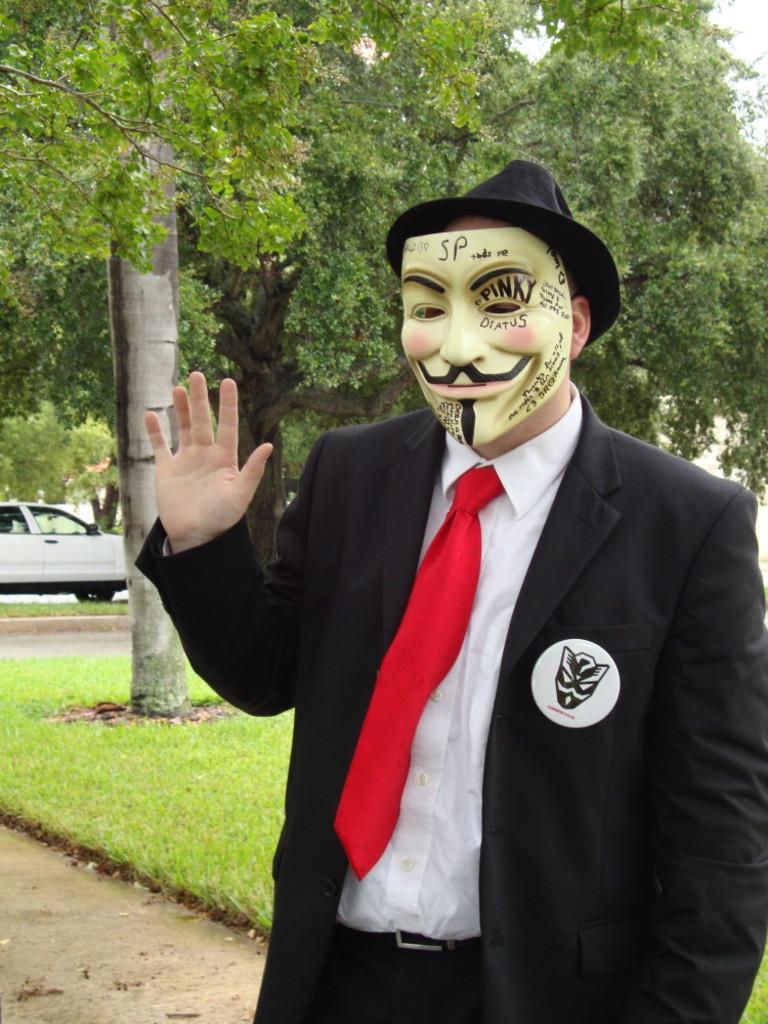How would you summarize this image in a sentence or two? In the foreground of the picture we can see a person wearing mask. In the middle of the picture there are trees, car, grass and path. In the top right corner we can see sky. 